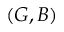Convert formula to latex. <formula><loc_0><loc_0><loc_500><loc_500>( G , B )</formula> 